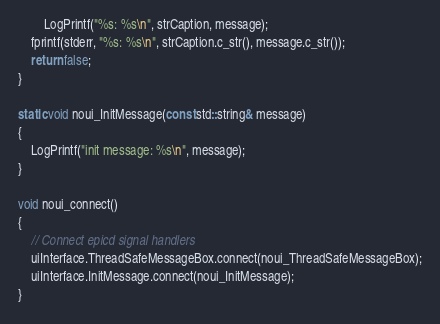<code> <loc_0><loc_0><loc_500><loc_500><_C++_>        LogPrintf("%s: %s\n", strCaption, message);
    fprintf(stderr, "%s: %s\n", strCaption.c_str(), message.c_str());
    return false;
}

static void noui_InitMessage(const std::string& message)
{
    LogPrintf("init message: %s\n", message);
}

void noui_connect()
{
    // Connect epicd signal handlers
    uiInterface.ThreadSafeMessageBox.connect(noui_ThreadSafeMessageBox);
    uiInterface.InitMessage.connect(noui_InitMessage);
}
</code> 